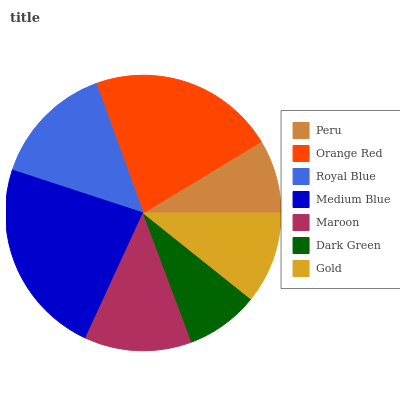Is Dark Green the minimum?
Answer yes or no. Yes. Is Medium Blue the maximum?
Answer yes or no. Yes. Is Orange Red the minimum?
Answer yes or no. No. Is Orange Red the maximum?
Answer yes or no. No. Is Orange Red greater than Peru?
Answer yes or no. Yes. Is Peru less than Orange Red?
Answer yes or no. Yes. Is Peru greater than Orange Red?
Answer yes or no. No. Is Orange Red less than Peru?
Answer yes or no. No. Is Maroon the high median?
Answer yes or no. Yes. Is Maroon the low median?
Answer yes or no. Yes. Is Royal Blue the high median?
Answer yes or no. No. Is Peru the low median?
Answer yes or no. No. 